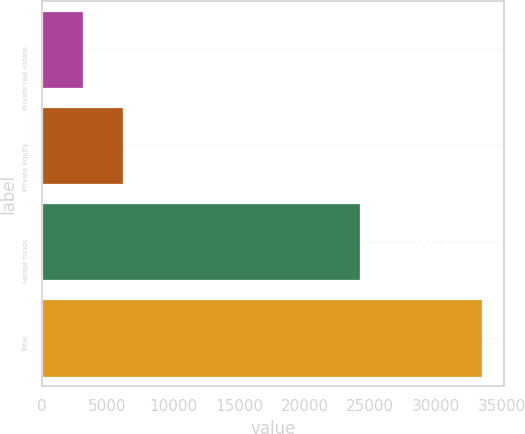Convert chart to OTSL. <chart><loc_0><loc_0><loc_500><loc_500><bar_chart><fcel>Private real estate<fcel>Private equity<fcel>Hedge funds<fcel>Total<nl><fcel>3123<fcel>6199<fcel>24174<fcel>33496<nl></chart> 